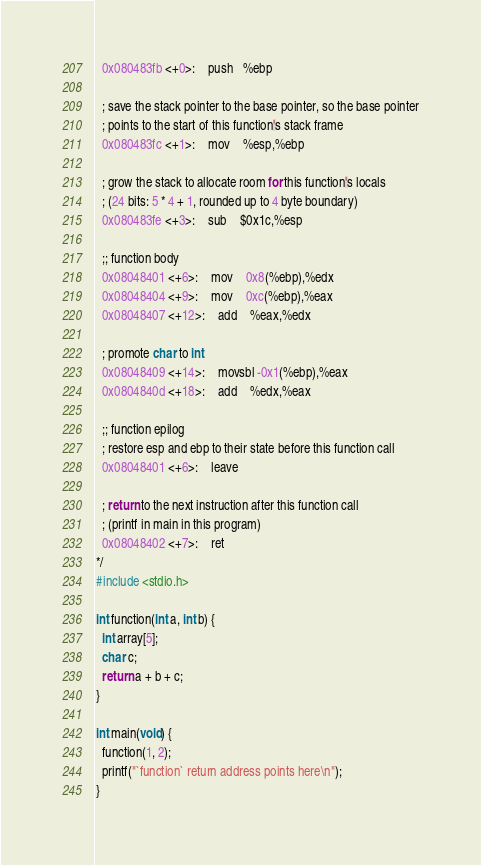Convert code to text. <code><loc_0><loc_0><loc_500><loc_500><_C_>  0x080483fb <+0>:	push   %ebp

  ; save the stack pointer to the base pointer, so the base pointer
  ; points to the start of this function's stack frame
  0x080483fc <+1>:	mov    %esp,%ebp

  ; grow the stack to allocate room for this function's locals
  ; (24 bits: 5 * 4 + 1, rounded up to 4 byte boundary)
  0x080483fe <+3>:	sub    $0x1c,%esp

  ;; function body
  0x08048401 <+6>:	mov    0x8(%ebp),%edx
  0x08048404 <+9>:	mov    0xc(%ebp),%eax
  0x08048407 <+12>:	add    %eax,%edx

  ; promote char to int
  0x08048409 <+14>:	movsbl -0x1(%ebp),%eax
  0x0804840d <+18>:	add    %edx,%eax

  ;; function epilog
  ; restore esp and ebp to their state before this function call
  0x08048401 <+6>:	leave

  ; return to the next instruction after this function call
  ; (printf in main in this program)
  0x08048402 <+7>:	ret
*/
#include <stdio.h>

int function(int a, int b) {
  int array[5];
  char c;
  return a + b + c;
}

int main(void) {
  function(1, 2);
  printf("`function` return address points here\n");
}
</code> 